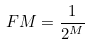Convert formula to latex. <formula><loc_0><loc_0><loc_500><loc_500>\ F { M } = \frac { 1 } { 2 ^ { M } }</formula> 